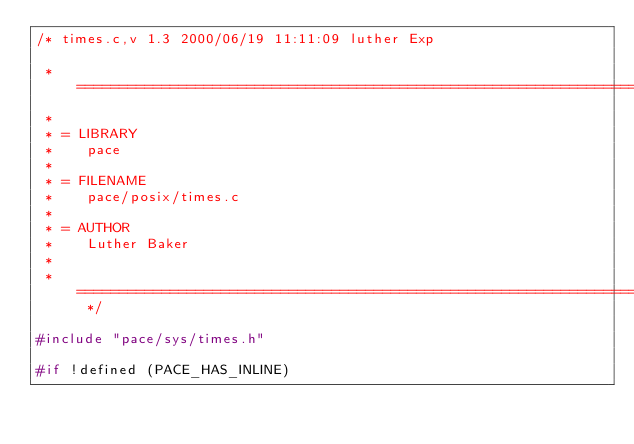Convert code to text. <code><loc_0><loc_0><loc_500><loc_500><_C_>/* times.c,v 1.3 2000/06/19 11:11:09 luther Exp

 * =============================================================================
 *
 * = LIBRARY
 *    pace
 *
 * = FILENAME
 *    pace/posix/times.c
 *
 * = AUTHOR
 *    Luther Baker
 *
 * ============================================================================= */

#include "pace/sys/times.h"

#if !defined (PACE_HAS_INLINE)</code> 